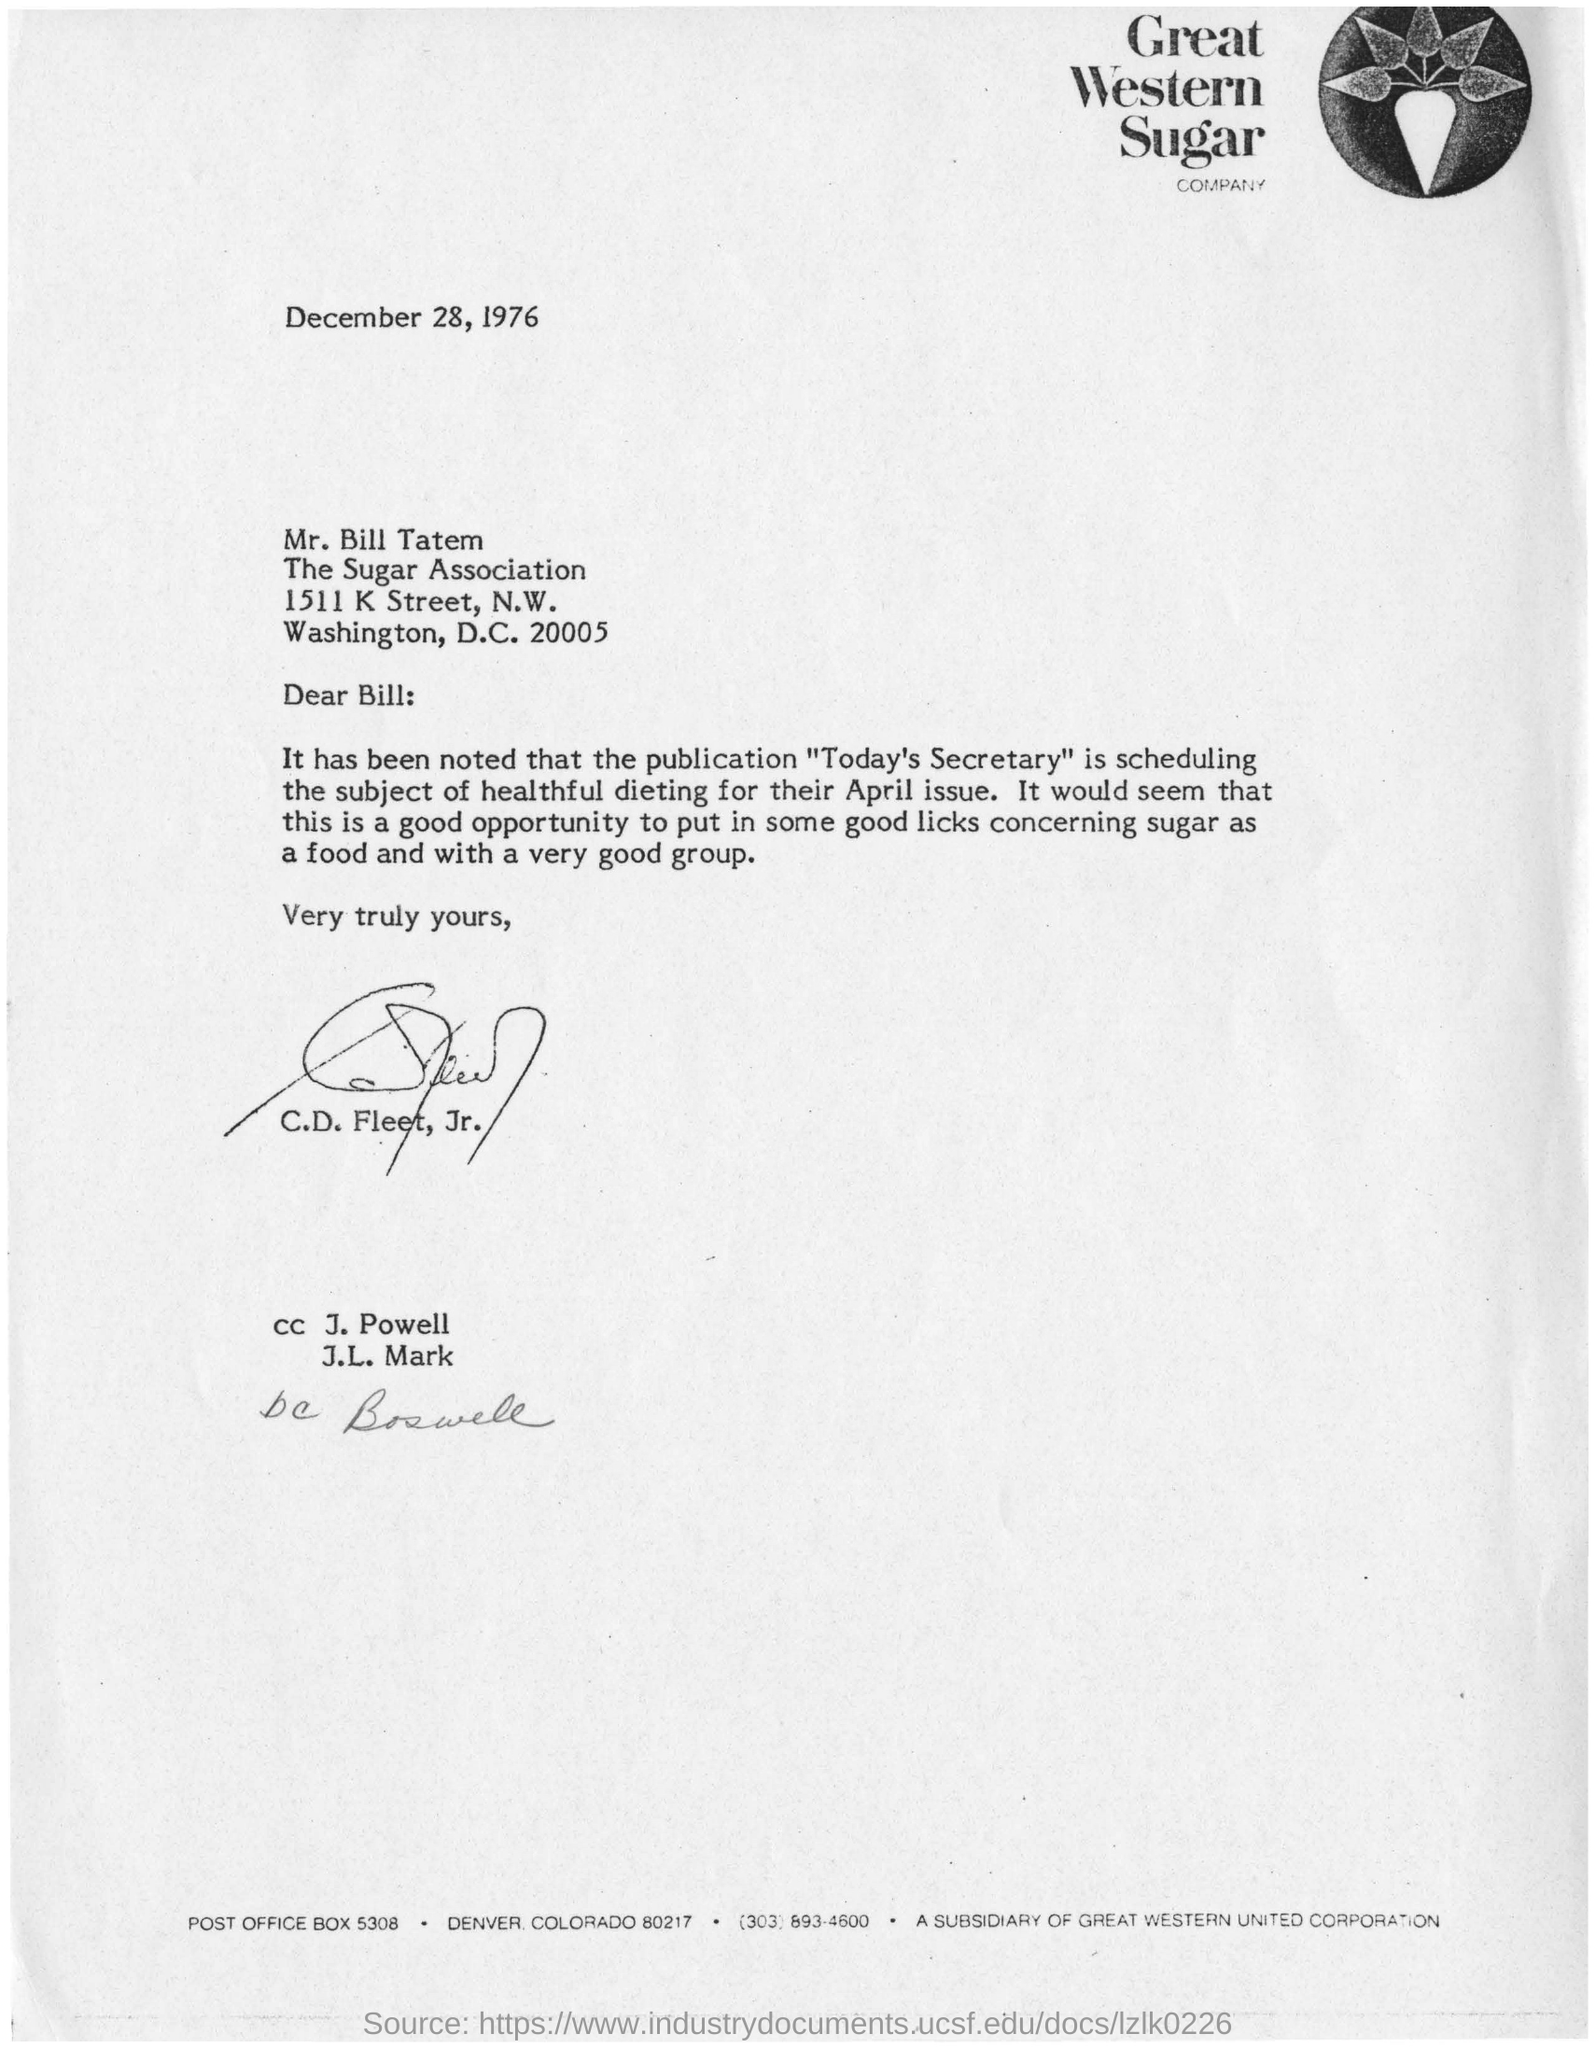Which company is mentioned in the letter head?
Your answer should be very brief. Great Western Sugar Company. What is the date mentioned in this letter?
Offer a terse response. December 28, 1976. Who is the addressee in this letter?
Provide a succinct answer. Mr. Bill Tatem. Who is the sender of this letter?
Provide a short and direct response. C.D. Fleet, Jr. What is the subject scheduled for the publication in "Today's Secretary"?
Keep it short and to the point. Healthful dieting. In which city, The Sugar Association is located?
Make the answer very short. Washington. 